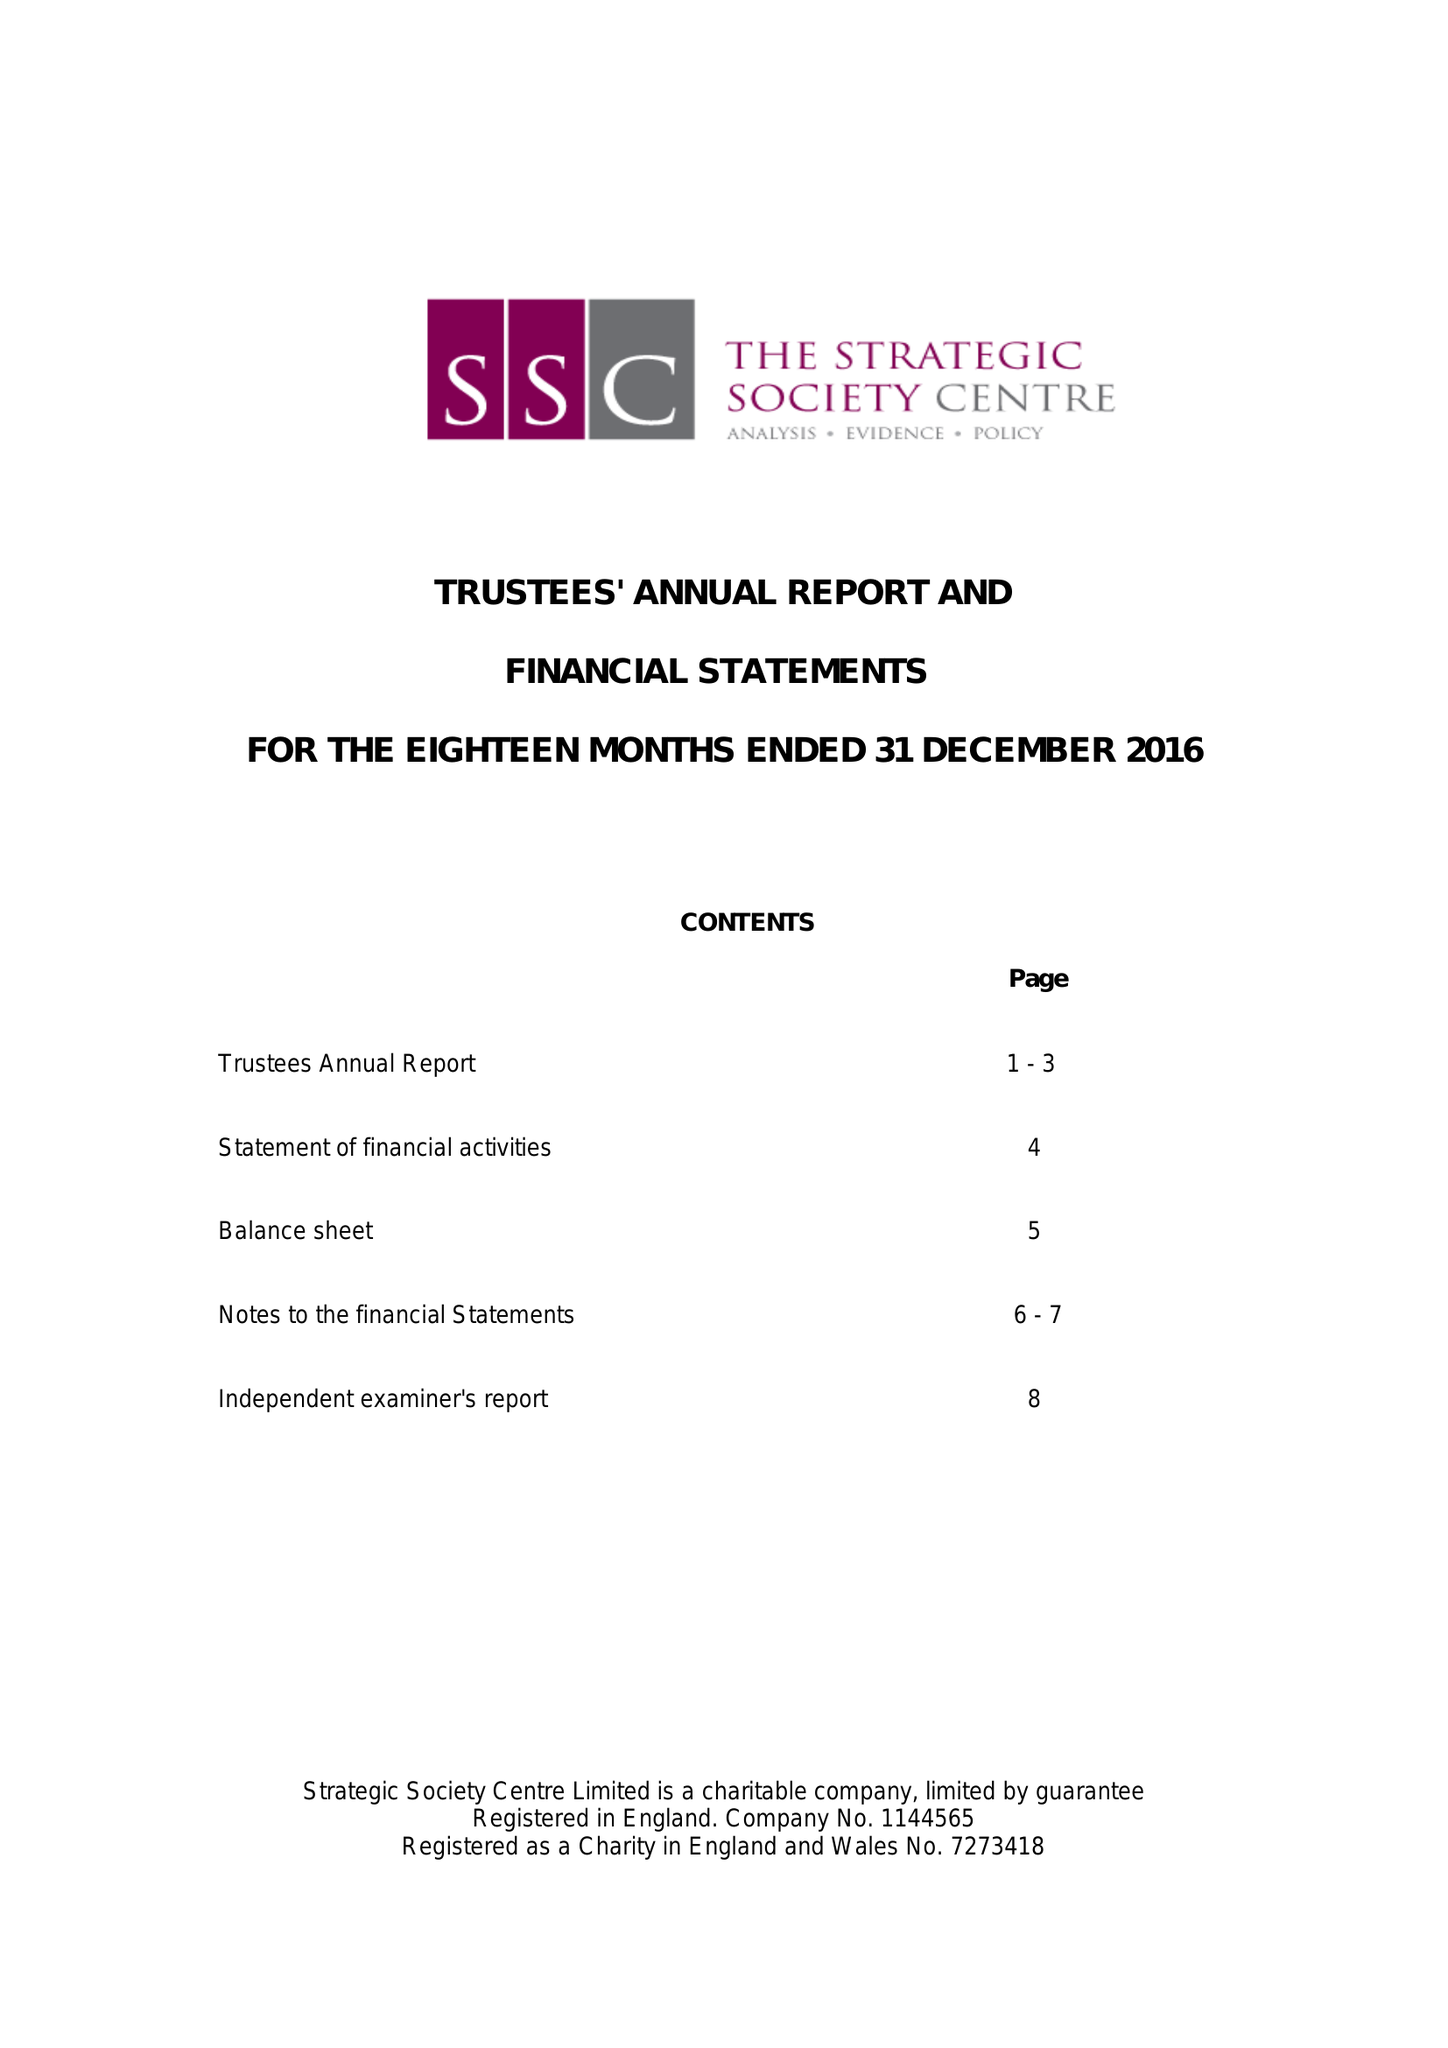What is the value for the charity_name?
Answer the question using a single word or phrase. Strategic Society Centre Ltd. 